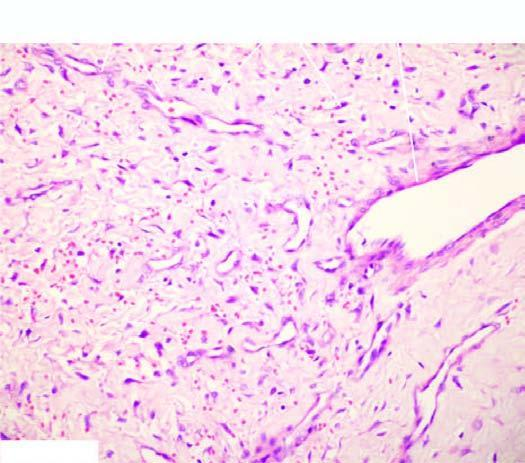did some blood vessels have incomplete muscle coat?
Answer the question using a single word or phrase. Yes 